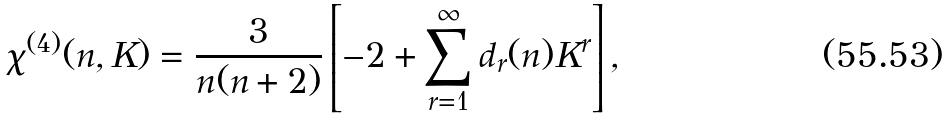Convert formula to latex. <formula><loc_0><loc_0><loc_500><loc_500>\chi ^ { ( 4 ) } ( n , K ) = \frac { 3 } { n ( n + 2 ) } \left [ - 2 + \sum _ { r = 1 } ^ { \infty } d _ { r } ( n ) K ^ { r } \right ] ,</formula> 